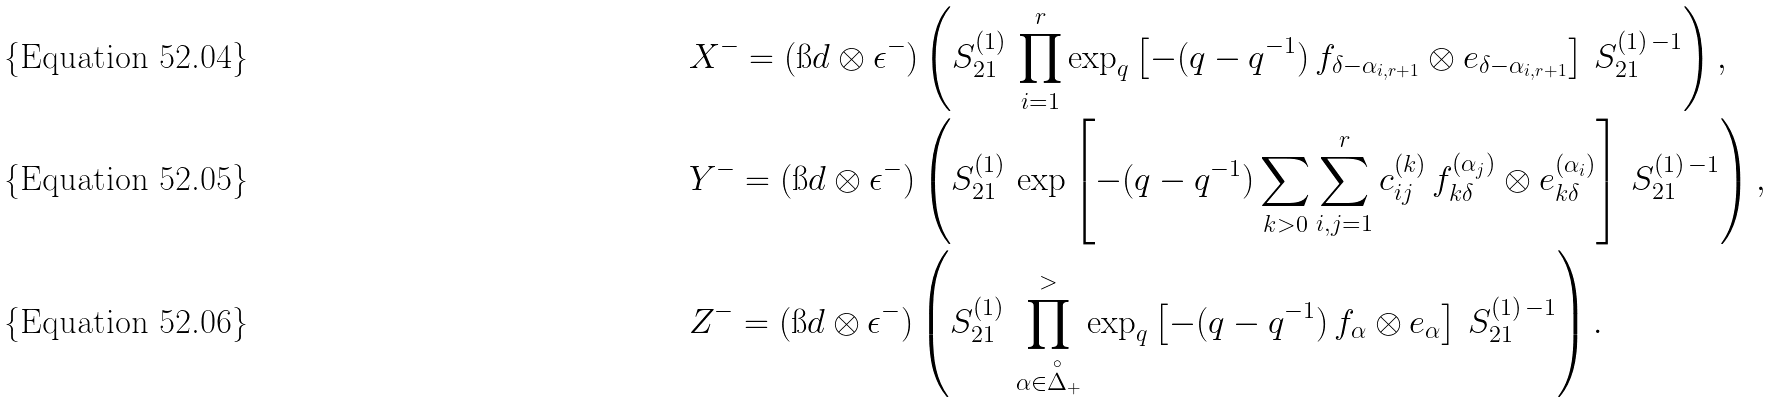<formula> <loc_0><loc_0><loc_500><loc_500>& X ^ { - } = ( \i d \otimes \epsilon ^ { - } ) \left ( S _ { 2 1 } ^ { ( 1 ) } \, \prod _ { i = 1 } ^ { r } \exp _ { q } \left [ - ( q - q ^ { - 1 } ) \, f _ { \delta - \alpha _ { i , r + 1 } } \otimes e _ { \delta - \alpha _ { i , r + 1 } } \right ] \, S _ { 2 1 } ^ { ( 1 ) \, - 1 } \right ) , \\ & Y ^ { - } = ( \i d \otimes \epsilon ^ { - } ) \left ( S _ { 2 1 } ^ { ( 1 ) } \, \exp \left [ - ( q - q ^ { - 1 } ) \sum _ { k > 0 } \sum _ { i , j = 1 } ^ { r } c _ { i j } ^ { ( k ) } \, f _ { k \delta } ^ { ( \alpha _ { j } ) } \otimes e _ { k \delta } ^ { ( \alpha _ { i } ) } \right ] \, S _ { 2 1 } ^ { ( 1 ) \, - 1 } \right ) , \\ & Z ^ { - } = ( \i d \otimes \epsilon ^ { - } ) \left ( S _ { 2 1 } ^ { ( 1 ) } \, \prod _ { \alpha \in \overset { \circ } { \Delta } _ { + } } ^ { > } \exp _ { q } \left [ - ( q - q ^ { - 1 } ) \, f _ { \alpha } \otimes e _ { \alpha } \right ] \, S _ { 2 1 } ^ { ( 1 ) \, - 1 } \right ) .</formula> 